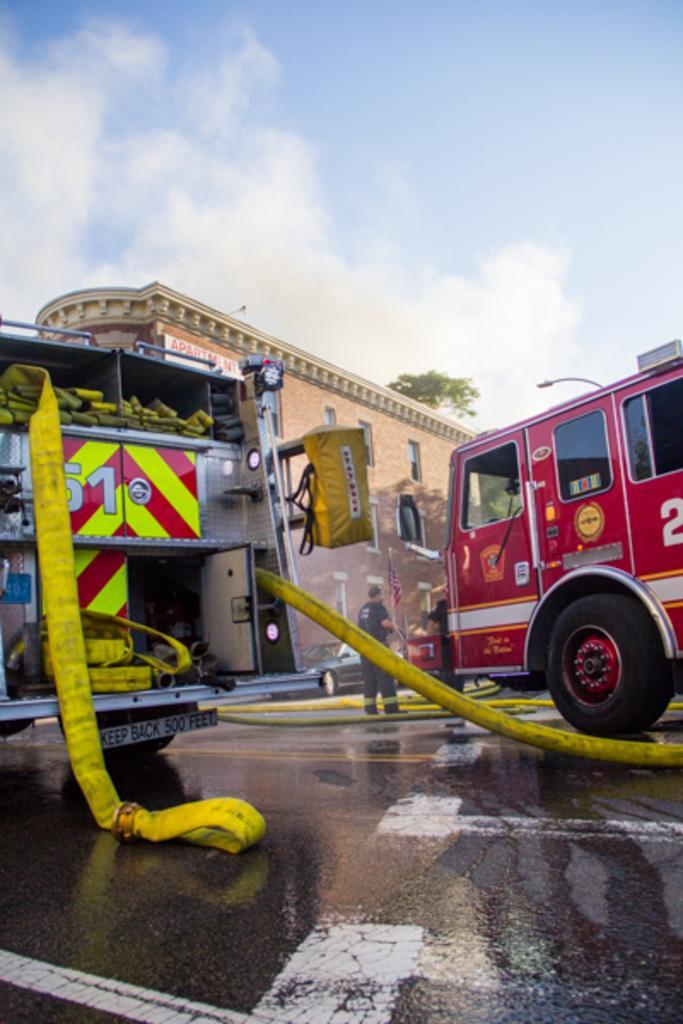In one or two sentences, can you explain what this image depicts? In this image I can see road and on it I can see red colour fire truck and one more vehicle over here. I can also see white lines on road and in the background I can see a building, a car, a tree and a person is standing. I can also see clouds and the sky. 